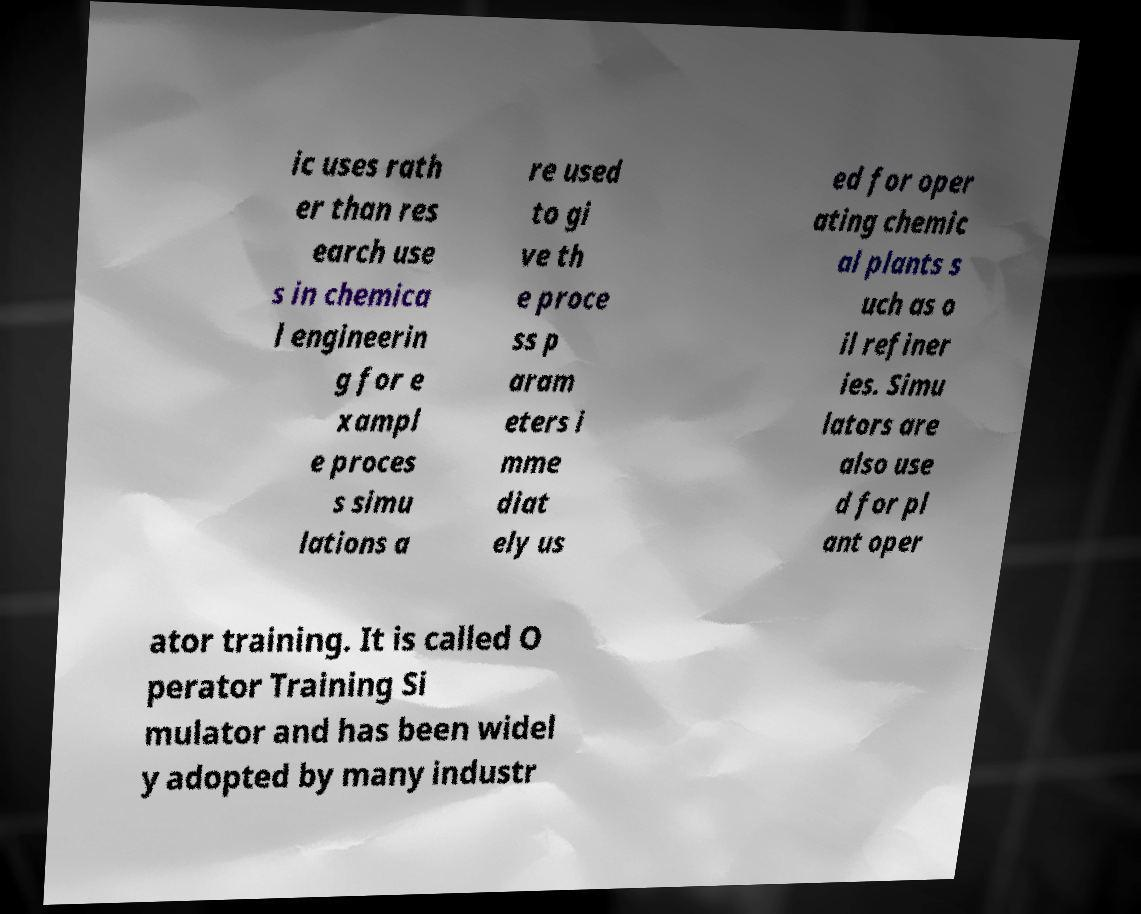Please read and relay the text visible in this image. What does it say? ic uses rath er than res earch use s in chemica l engineerin g for e xampl e proces s simu lations a re used to gi ve th e proce ss p aram eters i mme diat ely us ed for oper ating chemic al plants s uch as o il refiner ies. Simu lators are also use d for pl ant oper ator training. It is called O perator Training Si mulator and has been widel y adopted by many industr 